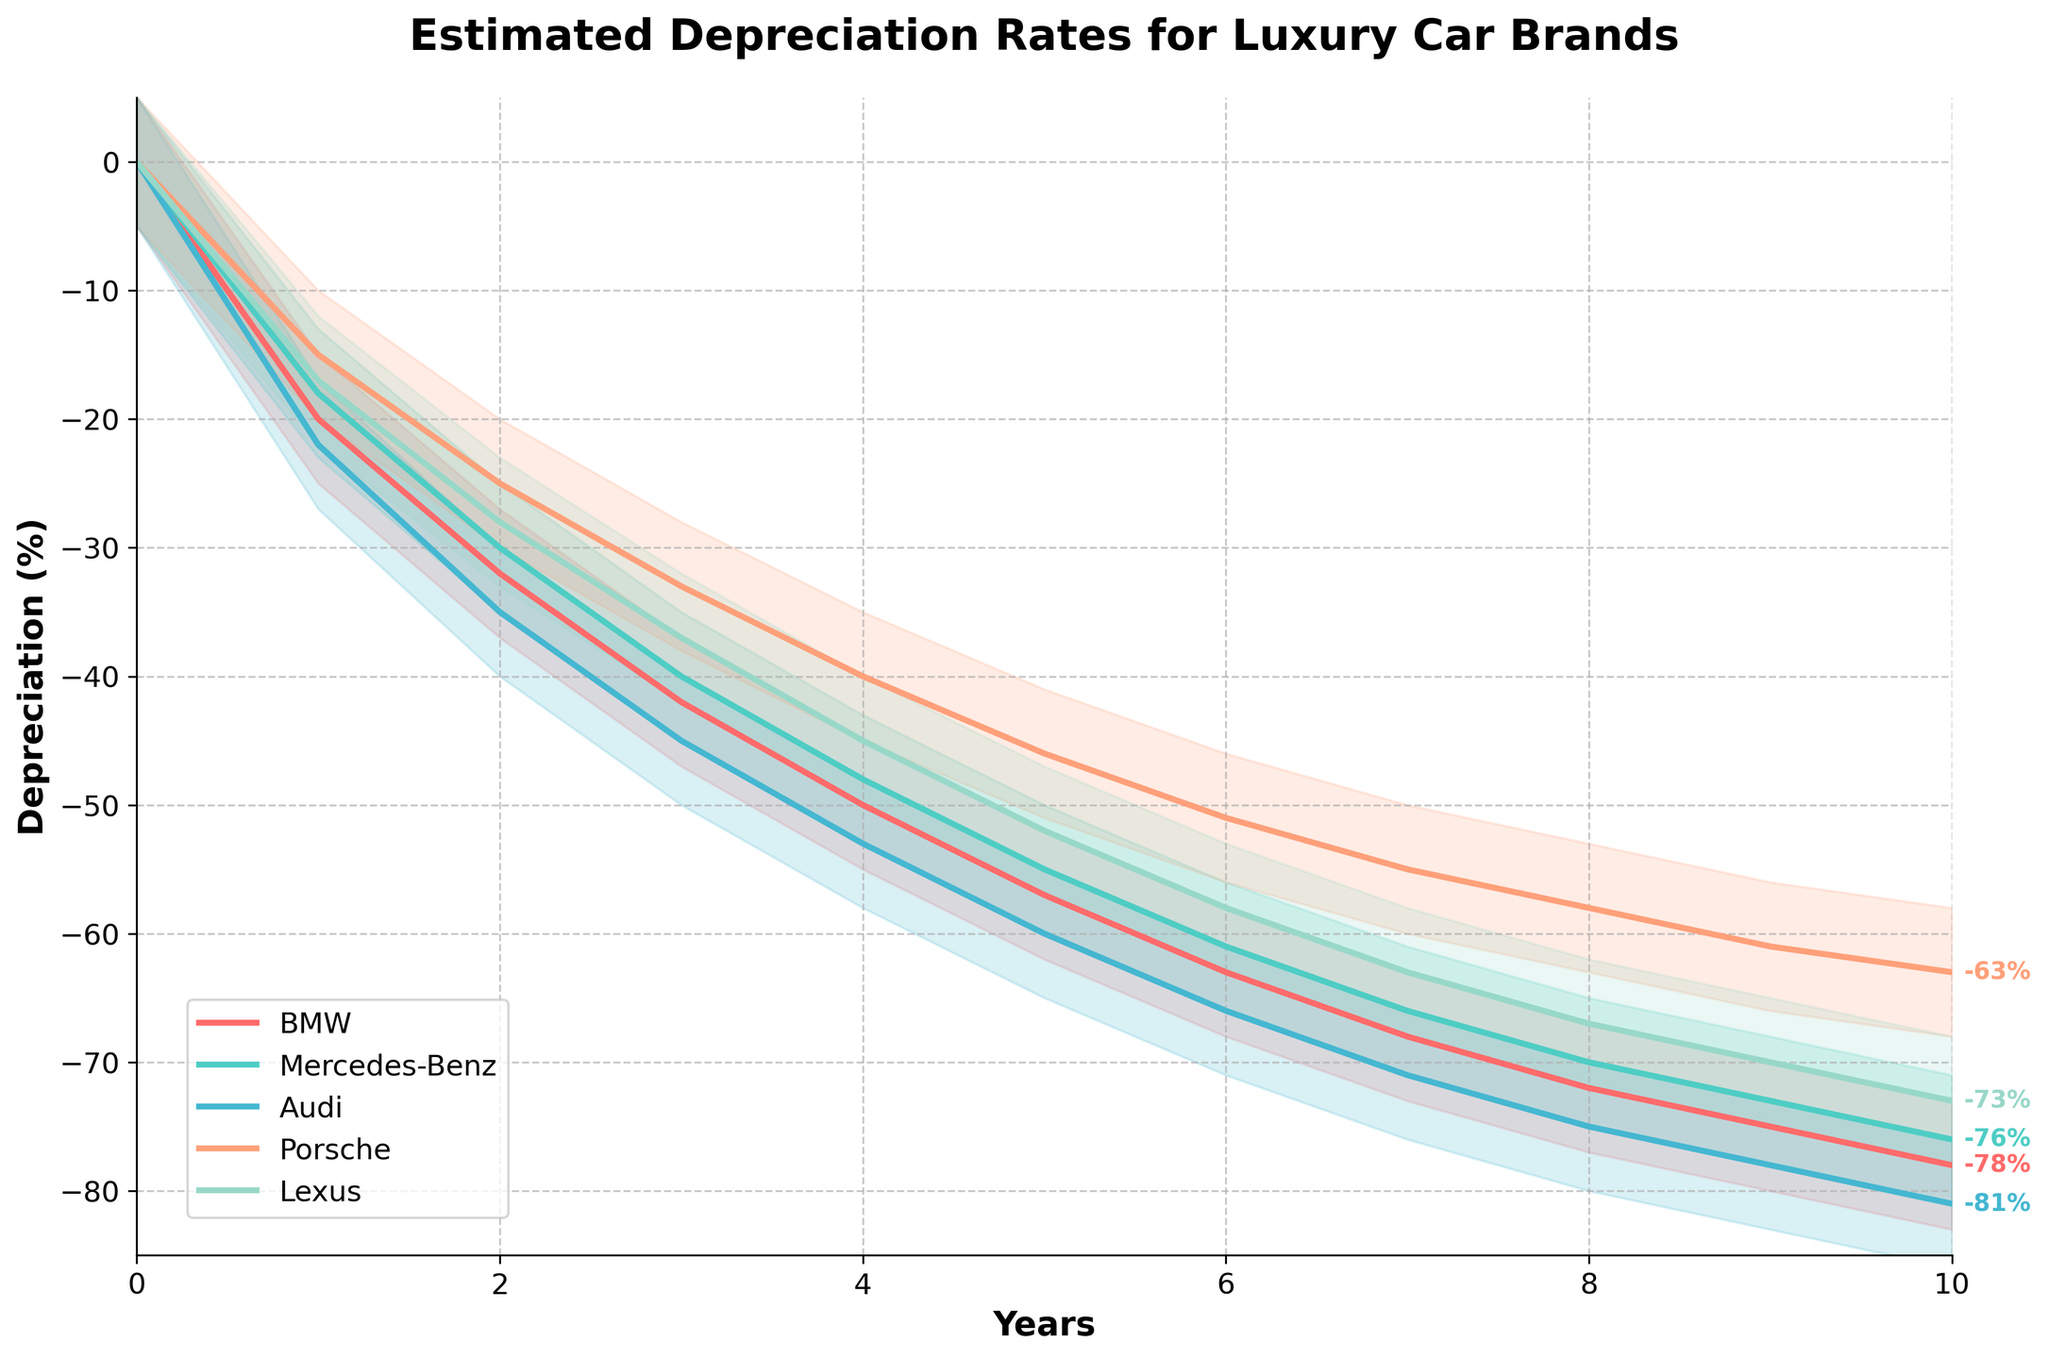What is the title of the chart? The title of the chart is prominently displayed at the top, and it reads "Estimated Depreciation Rates for Luxury Car Brands."
Answer: Estimated Depreciation Rates for Luxury Car Brands What is the depreciation rate of Mercedes-Benz in Year 5? To find this, locate the line corresponding to Mercedes-Benz and find its value at Year 5. The chart shows -55%.
Answer: -55% Between what years does Audi experience a depreciation drop from -22% to -45%? Locate the line for Audi and find the years where it moves from -22% to -45%. This drop happens between Year 1 and Year 3.
Answer: Year 1 and Year 3 Which brand retains the highest value by Year 10? Compare final values for all brands at Year 10. Porsche retains the highest value with its depreciation at -63%.
Answer: Porsche What is the average depreciation rate for Lexus over the 10-year period? Sum the depreciation rates for Lexus from Year 0 to Year 10 and then divide by the number of years (11). Calculation: (0 - 17 - 28 - 37 - 45 - 52 - 58 - 63 - 67 - 70 - 73) / 11 = -456 / 11 = -41.45%.
Answer: -41.45% During which year do BMW and Lexus have nearly the same depreciation rate? Observe the lines for BMW and Lexus to find the year where their values are closest. In Year 1, BMW is at -20% and Lexus is at -17%, nearly the same.
Answer: Year 1 By how much does the depreciation rate for Porsche exceed that of Lexus in Year 4? Find the values for both brands at Year 4 and calculate the difference. Porsche is at -40% and Lexus at -45%. Difference: -45 - (-40) = -5%.
Answer: -5% If a customer is particularly concerned about depreciation, which brand appears to be the least risky over the first 5 years? Compare the depreciation rates for all brands over the first 5 years. Porsche has the least depreciation at -46% in Year 5.
Answer: Porsche What is the difference in depreciation rates between Audi and Mercedes-Benz in Year 6? Find the values for Audi and Mercedes-Benz in Year 6 and calculate the difference. Audi is at -66% and Mercedes-Benz at -61%. Difference: -66 - (-61) = -5%.
Answer: -5% 